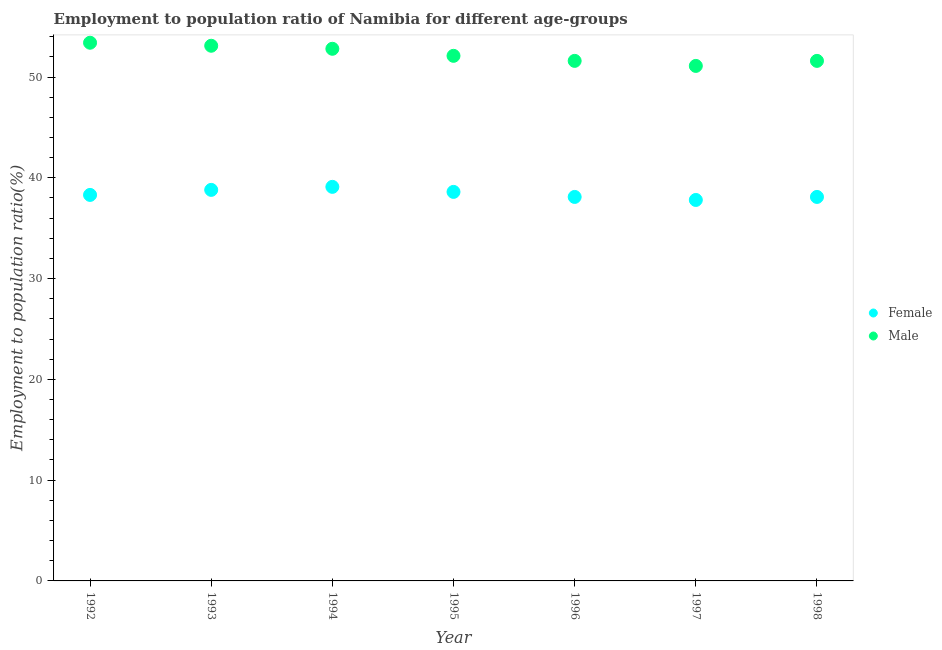How many different coloured dotlines are there?
Offer a very short reply. 2. What is the employment to population ratio(male) in 1998?
Provide a succinct answer. 51.6. Across all years, what is the maximum employment to population ratio(female)?
Offer a very short reply. 39.1. Across all years, what is the minimum employment to population ratio(male)?
Offer a terse response. 51.1. What is the total employment to population ratio(female) in the graph?
Ensure brevity in your answer.  268.8. What is the difference between the employment to population ratio(male) in 1994 and that in 1998?
Ensure brevity in your answer.  1.2. What is the difference between the employment to population ratio(male) in 1994 and the employment to population ratio(female) in 1995?
Keep it short and to the point. 14.2. What is the average employment to population ratio(male) per year?
Provide a succinct answer. 52.24. In the year 1995, what is the difference between the employment to population ratio(female) and employment to population ratio(male)?
Offer a terse response. -13.5. What is the ratio of the employment to population ratio(female) in 1992 to that in 1994?
Ensure brevity in your answer.  0.98. Is the employment to population ratio(male) in 1994 less than that in 1998?
Make the answer very short. No. Is the difference between the employment to population ratio(female) in 1997 and 1998 greater than the difference between the employment to population ratio(male) in 1997 and 1998?
Provide a succinct answer. Yes. What is the difference between the highest and the second highest employment to population ratio(male)?
Give a very brief answer. 0.3. What is the difference between the highest and the lowest employment to population ratio(male)?
Make the answer very short. 2.3. In how many years, is the employment to population ratio(female) greater than the average employment to population ratio(female) taken over all years?
Provide a succinct answer. 3. Are the values on the major ticks of Y-axis written in scientific E-notation?
Provide a succinct answer. No. Does the graph contain any zero values?
Make the answer very short. No. Where does the legend appear in the graph?
Offer a terse response. Center right. How many legend labels are there?
Provide a short and direct response. 2. How are the legend labels stacked?
Ensure brevity in your answer.  Vertical. What is the title of the graph?
Offer a terse response. Employment to population ratio of Namibia for different age-groups. Does "From Government" appear as one of the legend labels in the graph?
Your answer should be compact. No. What is the Employment to population ratio(%) in Female in 1992?
Make the answer very short. 38.3. What is the Employment to population ratio(%) in Male in 1992?
Your response must be concise. 53.4. What is the Employment to population ratio(%) of Female in 1993?
Your response must be concise. 38.8. What is the Employment to population ratio(%) in Male in 1993?
Give a very brief answer. 53.1. What is the Employment to population ratio(%) of Female in 1994?
Give a very brief answer. 39.1. What is the Employment to population ratio(%) of Male in 1994?
Provide a short and direct response. 52.8. What is the Employment to population ratio(%) of Female in 1995?
Offer a very short reply. 38.6. What is the Employment to population ratio(%) in Male in 1995?
Offer a terse response. 52.1. What is the Employment to population ratio(%) of Female in 1996?
Your response must be concise. 38.1. What is the Employment to population ratio(%) of Male in 1996?
Your answer should be very brief. 51.6. What is the Employment to population ratio(%) in Female in 1997?
Keep it short and to the point. 37.8. What is the Employment to population ratio(%) of Male in 1997?
Make the answer very short. 51.1. What is the Employment to population ratio(%) of Female in 1998?
Ensure brevity in your answer.  38.1. What is the Employment to population ratio(%) of Male in 1998?
Your response must be concise. 51.6. Across all years, what is the maximum Employment to population ratio(%) in Female?
Make the answer very short. 39.1. Across all years, what is the maximum Employment to population ratio(%) in Male?
Make the answer very short. 53.4. Across all years, what is the minimum Employment to population ratio(%) in Female?
Your answer should be very brief. 37.8. Across all years, what is the minimum Employment to population ratio(%) in Male?
Offer a terse response. 51.1. What is the total Employment to population ratio(%) of Female in the graph?
Provide a succinct answer. 268.8. What is the total Employment to population ratio(%) of Male in the graph?
Your response must be concise. 365.7. What is the difference between the Employment to population ratio(%) of Female in 1992 and that in 1993?
Ensure brevity in your answer.  -0.5. What is the difference between the Employment to population ratio(%) in Male in 1992 and that in 1993?
Keep it short and to the point. 0.3. What is the difference between the Employment to population ratio(%) in Male in 1992 and that in 1994?
Keep it short and to the point. 0.6. What is the difference between the Employment to population ratio(%) of Male in 1992 and that in 1998?
Provide a short and direct response. 1.8. What is the difference between the Employment to population ratio(%) in Female in 1993 and that in 1994?
Make the answer very short. -0.3. What is the difference between the Employment to population ratio(%) in Male in 1993 and that in 1994?
Ensure brevity in your answer.  0.3. What is the difference between the Employment to population ratio(%) in Male in 1993 and that in 1995?
Your answer should be compact. 1. What is the difference between the Employment to population ratio(%) in Female in 1993 and that in 1996?
Keep it short and to the point. 0.7. What is the difference between the Employment to population ratio(%) of Male in 1993 and that in 1996?
Make the answer very short. 1.5. What is the difference between the Employment to population ratio(%) in Female in 1993 and that in 1997?
Offer a very short reply. 1. What is the difference between the Employment to population ratio(%) of Female in 1994 and that in 1995?
Offer a very short reply. 0.5. What is the difference between the Employment to population ratio(%) in Male in 1994 and that in 1995?
Give a very brief answer. 0.7. What is the difference between the Employment to population ratio(%) of Male in 1994 and that in 1997?
Keep it short and to the point. 1.7. What is the difference between the Employment to population ratio(%) in Female in 1994 and that in 1998?
Your answer should be very brief. 1. What is the difference between the Employment to population ratio(%) in Male in 1994 and that in 1998?
Your answer should be very brief. 1.2. What is the difference between the Employment to population ratio(%) in Female in 1995 and that in 1996?
Provide a succinct answer. 0.5. What is the difference between the Employment to population ratio(%) in Male in 1995 and that in 1996?
Offer a terse response. 0.5. What is the difference between the Employment to population ratio(%) in Male in 1995 and that in 1998?
Provide a short and direct response. 0.5. What is the difference between the Employment to population ratio(%) in Female in 1996 and that in 1997?
Make the answer very short. 0.3. What is the difference between the Employment to population ratio(%) in Male in 1996 and that in 1997?
Provide a short and direct response. 0.5. What is the difference between the Employment to population ratio(%) in Female in 1996 and that in 1998?
Your response must be concise. 0. What is the difference between the Employment to population ratio(%) of Male in 1996 and that in 1998?
Keep it short and to the point. 0. What is the difference between the Employment to population ratio(%) in Male in 1997 and that in 1998?
Give a very brief answer. -0.5. What is the difference between the Employment to population ratio(%) of Female in 1992 and the Employment to population ratio(%) of Male in 1993?
Offer a terse response. -14.8. What is the difference between the Employment to population ratio(%) of Female in 1992 and the Employment to population ratio(%) of Male in 1995?
Provide a succinct answer. -13.8. What is the difference between the Employment to population ratio(%) in Female in 1992 and the Employment to population ratio(%) in Male in 1998?
Offer a very short reply. -13.3. What is the difference between the Employment to population ratio(%) in Female in 1994 and the Employment to population ratio(%) in Male in 1995?
Your response must be concise. -13. What is the difference between the Employment to population ratio(%) of Female in 1995 and the Employment to population ratio(%) of Male in 1996?
Provide a short and direct response. -13. What is the difference between the Employment to population ratio(%) of Female in 1995 and the Employment to population ratio(%) of Male in 1997?
Offer a terse response. -12.5. What is the difference between the Employment to population ratio(%) of Female in 1997 and the Employment to population ratio(%) of Male in 1998?
Ensure brevity in your answer.  -13.8. What is the average Employment to population ratio(%) of Female per year?
Provide a succinct answer. 38.4. What is the average Employment to population ratio(%) in Male per year?
Your answer should be compact. 52.24. In the year 1992, what is the difference between the Employment to population ratio(%) of Female and Employment to population ratio(%) of Male?
Ensure brevity in your answer.  -15.1. In the year 1993, what is the difference between the Employment to population ratio(%) of Female and Employment to population ratio(%) of Male?
Provide a succinct answer. -14.3. In the year 1994, what is the difference between the Employment to population ratio(%) in Female and Employment to population ratio(%) in Male?
Your answer should be very brief. -13.7. In the year 1997, what is the difference between the Employment to population ratio(%) in Female and Employment to population ratio(%) in Male?
Make the answer very short. -13.3. In the year 1998, what is the difference between the Employment to population ratio(%) in Female and Employment to population ratio(%) in Male?
Provide a succinct answer. -13.5. What is the ratio of the Employment to population ratio(%) in Female in 1992 to that in 1993?
Your response must be concise. 0.99. What is the ratio of the Employment to population ratio(%) of Male in 1992 to that in 1993?
Keep it short and to the point. 1.01. What is the ratio of the Employment to population ratio(%) in Female in 1992 to that in 1994?
Your response must be concise. 0.98. What is the ratio of the Employment to population ratio(%) of Male in 1992 to that in 1994?
Keep it short and to the point. 1.01. What is the ratio of the Employment to population ratio(%) in Female in 1992 to that in 1995?
Offer a terse response. 0.99. What is the ratio of the Employment to population ratio(%) of Male in 1992 to that in 1995?
Offer a very short reply. 1.02. What is the ratio of the Employment to population ratio(%) of Female in 1992 to that in 1996?
Provide a short and direct response. 1.01. What is the ratio of the Employment to population ratio(%) in Male in 1992 to that in 1996?
Provide a short and direct response. 1.03. What is the ratio of the Employment to population ratio(%) in Female in 1992 to that in 1997?
Your answer should be compact. 1.01. What is the ratio of the Employment to population ratio(%) in Male in 1992 to that in 1997?
Make the answer very short. 1.04. What is the ratio of the Employment to population ratio(%) of Female in 1992 to that in 1998?
Offer a very short reply. 1.01. What is the ratio of the Employment to population ratio(%) in Male in 1992 to that in 1998?
Your answer should be compact. 1.03. What is the ratio of the Employment to population ratio(%) of Male in 1993 to that in 1994?
Your response must be concise. 1.01. What is the ratio of the Employment to population ratio(%) in Female in 1993 to that in 1995?
Give a very brief answer. 1.01. What is the ratio of the Employment to population ratio(%) of Male in 1993 to that in 1995?
Offer a terse response. 1.02. What is the ratio of the Employment to population ratio(%) of Female in 1993 to that in 1996?
Keep it short and to the point. 1.02. What is the ratio of the Employment to population ratio(%) of Male in 1993 to that in 1996?
Offer a terse response. 1.03. What is the ratio of the Employment to population ratio(%) of Female in 1993 to that in 1997?
Ensure brevity in your answer.  1.03. What is the ratio of the Employment to population ratio(%) of Male in 1993 to that in 1997?
Give a very brief answer. 1.04. What is the ratio of the Employment to population ratio(%) in Female in 1993 to that in 1998?
Your answer should be very brief. 1.02. What is the ratio of the Employment to population ratio(%) in Male in 1993 to that in 1998?
Offer a terse response. 1.03. What is the ratio of the Employment to population ratio(%) in Female in 1994 to that in 1995?
Provide a succinct answer. 1.01. What is the ratio of the Employment to population ratio(%) of Male in 1994 to that in 1995?
Keep it short and to the point. 1.01. What is the ratio of the Employment to population ratio(%) of Female in 1994 to that in 1996?
Ensure brevity in your answer.  1.03. What is the ratio of the Employment to population ratio(%) in Male in 1994 to that in 1996?
Make the answer very short. 1.02. What is the ratio of the Employment to population ratio(%) in Female in 1994 to that in 1997?
Offer a terse response. 1.03. What is the ratio of the Employment to population ratio(%) in Female in 1994 to that in 1998?
Give a very brief answer. 1.03. What is the ratio of the Employment to population ratio(%) in Male in 1994 to that in 1998?
Give a very brief answer. 1.02. What is the ratio of the Employment to population ratio(%) in Female in 1995 to that in 1996?
Make the answer very short. 1.01. What is the ratio of the Employment to population ratio(%) in Male in 1995 to that in 1996?
Ensure brevity in your answer.  1.01. What is the ratio of the Employment to population ratio(%) in Female in 1995 to that in 1997?
Offer a very short reply. 1.02. What is the ratio of the Employment to population ratio(%) in Male in 1995 to that in 1997?
Provide a short and direct response. 1.02. What is the ratio of the Employment to population ratio(%) in Female in 1995 to that in 1998?
Offer a terse response. 1.01. What is the ratio of the Employment to population ratio(%) in Male in 1995 to that in 1998?
Keep it short and to the point. 1.01. What is the ratio of the Employment to population ratio(%) in Female in 1996 to that in 1997?
Offer a very short reply. 1.01. What is the ratio of the Employment to population ratio(%) in Male in 1996 to that in 1997?
Offer a terse response. 1.01. What is the ratio of the Employment to population ratio(%) in Male in 1996 to that in 1998?
Make the answer very short. 1. What is the ratio of the Employment to population ratio(%) in Male in 1997 to that in 1998?
Your answer should be very brief. 0.99. What is the difference between the highest and the second highest Employment to population ratio(%) in Male?
Keep it short and to the point. 0.3. 